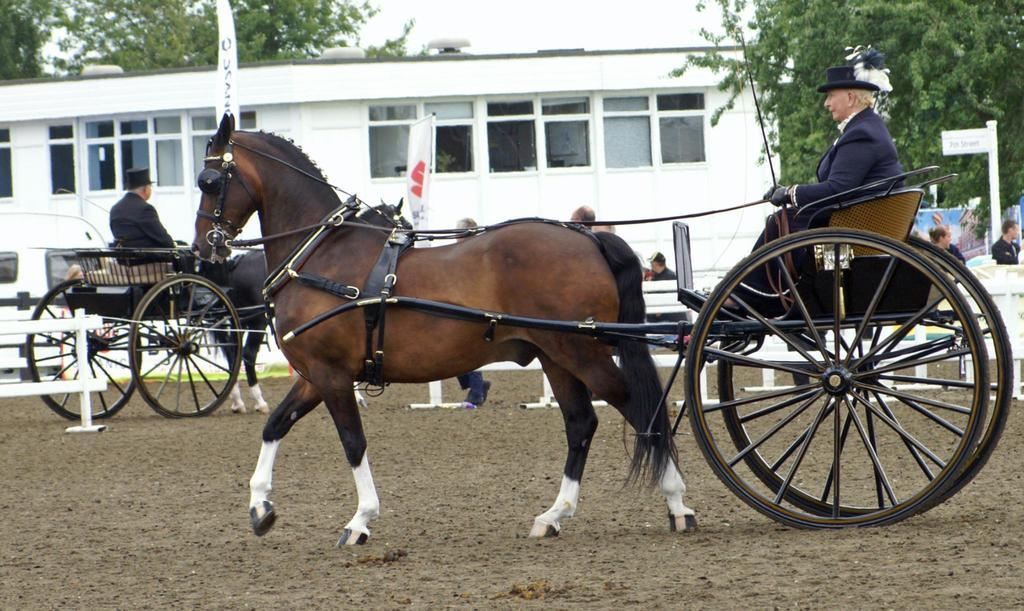What type of vehicle is in the image? There is a horse cart in the image. Who or what is present in the image besides the horse cart? There are people in the image. What can be seen in the distance in the image? There is a building and trees in the background of the image. Can you see a rabbit holding onto the horse cart for pleasure in the image? There is no rabbit present in the image, and the image does not depict any pleasure-related activities. 